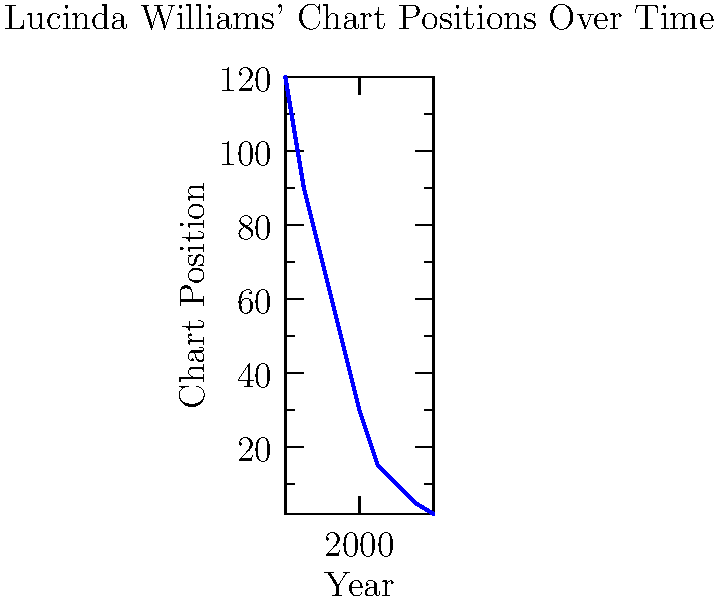Based on the line graph showing Lucinda Williams' chart positions over time, what was the approximate improvement in her chart position between 1990 and 2010? To determine the improvement in Lucinda Williams' chart position between 1990 and 2010, we need to:

1. Identify the chart positions for 1990 and 2010:
   - 1990: approximately 70
   - 2010: approximately 10

2. Calculate the difference:
   $70 - 10 = 60$

3. Interpret the result:
   A lower number indicates a better chart position. Therefore, moving from 70 to 10 is an improvement of 60 positions.

The graph shows a consistent upward trend (which actually represents improved chart positions) over time, with Lucinda Williams reaching higher chart positions as her career progressed.
Answer: 60 positions 